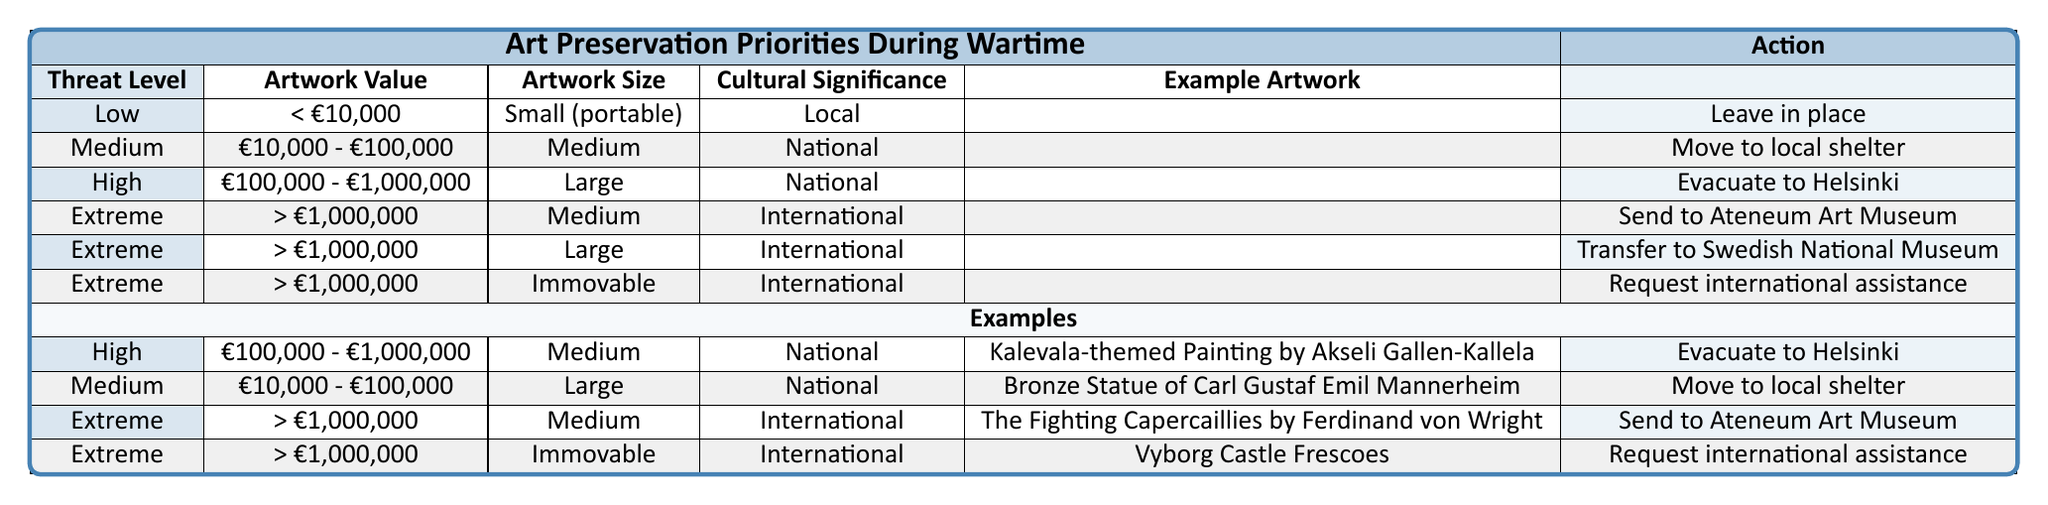What action is recommended for artworks valued between €10,000 and €100,000 during medium threat? The table indicates that for a medium threat level, artworks valued between €10,000 and €100,000 should be moved to a local shelter.
Answer: Move to local shelter Is it true that all artworks valued over €1,000,000 are transferred to Swedish National Museum? The table shows that not all artworks over €1,000,000 are sent to the Swedish National Museum; they are either sent to Ateneum Art Museum, transferred to Swedish National Museum, or request international assistance, depending on their size and cultural significance.
Answer: No How many different actions are recommended in cases of extreme threat? The table lists three actions for artworks valued over €1,000,000 during extreme threat: send to Ateneum Art Museum, transfer to Swedish National Museum, and request international assistance.
Answer: Three Which artwork is recommended to be evacuated to Helsinki? According to the table, the "Kalevala-themed Painting by Akseli Gallen-Kallela," which falls under the conditions of high threat, between €100,000 and €1,000,000 in value, and medium size, should be evacuated to Helsinki.
Answer: Kalevala-themed Painting by Akseli Gallen-Kallela What is the highest value threshold for artworks that can be left in place? The table shows that artworks valued less than €10,000 can be left in place during low threat.
Answer: Less than €10,000 